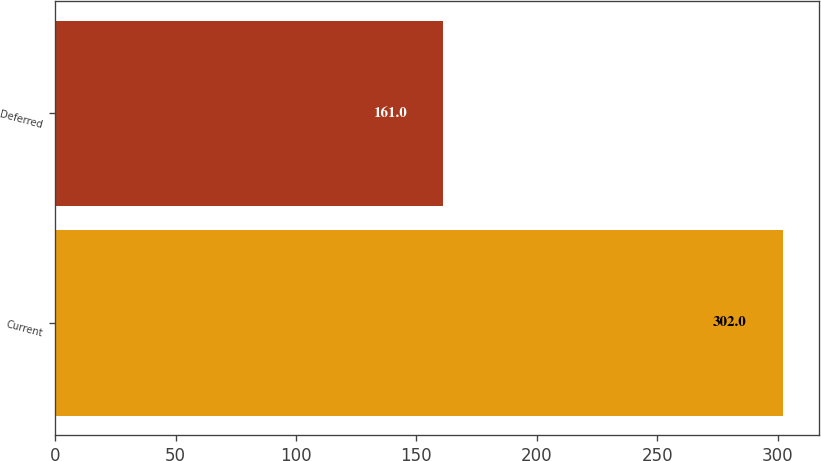<chart> <loc_0><loc_0><loc_500><loc_500><bar_chart><fcel>Current<fcel>Deferred<nl><fcel>302<fcel>161<nl></chart> 